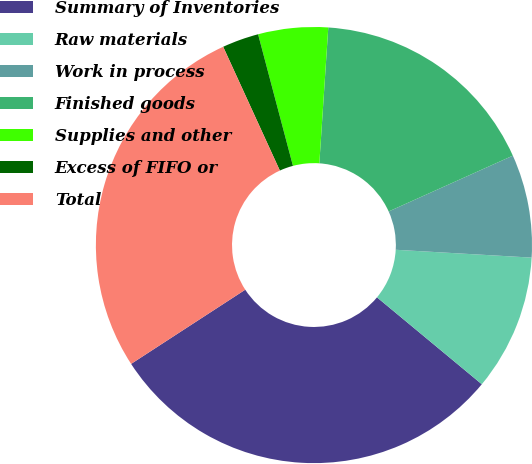Convert chart to OTSL. <chart><loc_0><loc_0><loc_500><loc_500><pie_chart><fcel>Summary of Inventories<fcel>Raw materials<fcel>Work in process<fcel>Finished goods<fcel>Supplies and other<fcel>Excess of FIFO or<fcel>Total<nl><fcel>29.81%<fcel>10.1%<fcel>7.64%<fcel>17.23%<fcel>5.17%<fcel>2.71%<fcel>27.34%<nl></chart> 